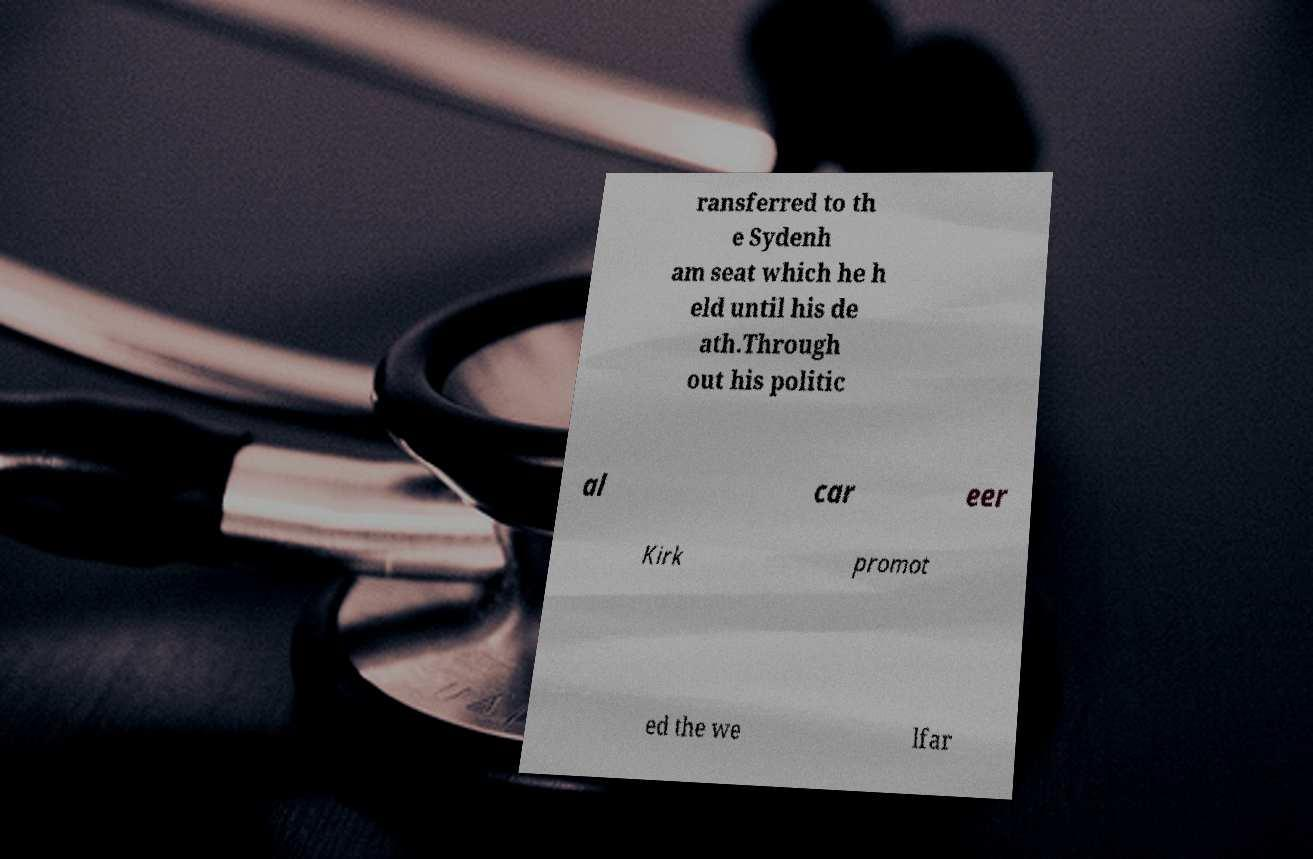Please identify and transcribe the text found in this image. ransferred to th e Sydenh am seat which he h eld until his de ath.Through out his politic al car eer Kirk promot ed the we lfar 